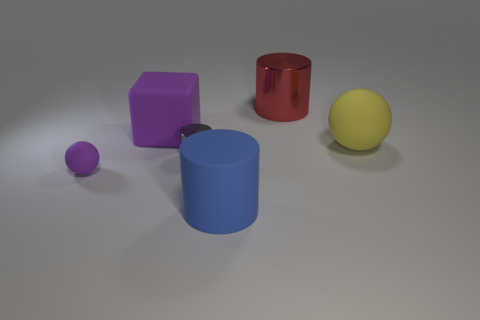There is a thing that is left of the big matte block; what material is it?
Your response must be concise. Rubber. There is a matte object right of the blue cylinder; does it have the same shape as the large object in front of the tiny matte sphere?
Ensure brevity in your answer.  No. There is a sphere that is the same color as the big rubber block; what is its material?
Ensure brevity in your answer.  Rubber. Are any big gray rubber objects visible?
Your response must be concise. No. What is the material of the other gray thing that is the same shape as the big shiny object?
Provide a short and direct response. Metal. Are there any large objects behind the big blue rubber object?
Give a very brief answer. Yes. Is the material of the cylinder that is in front of the tiny metal object the same as the big yellow sphere?
Make the answer very short. Yes. Is there a tiny matte ball that has the same color as the rubber cube?
Provide a succinct answer. Yes. What is the shape of the blue rubber object?
Your answer should be compact. Cylinder. The sphere on the right side of the large cylinder to the left of the big red object is what color?
Provide a short and direct response. Yellow. 